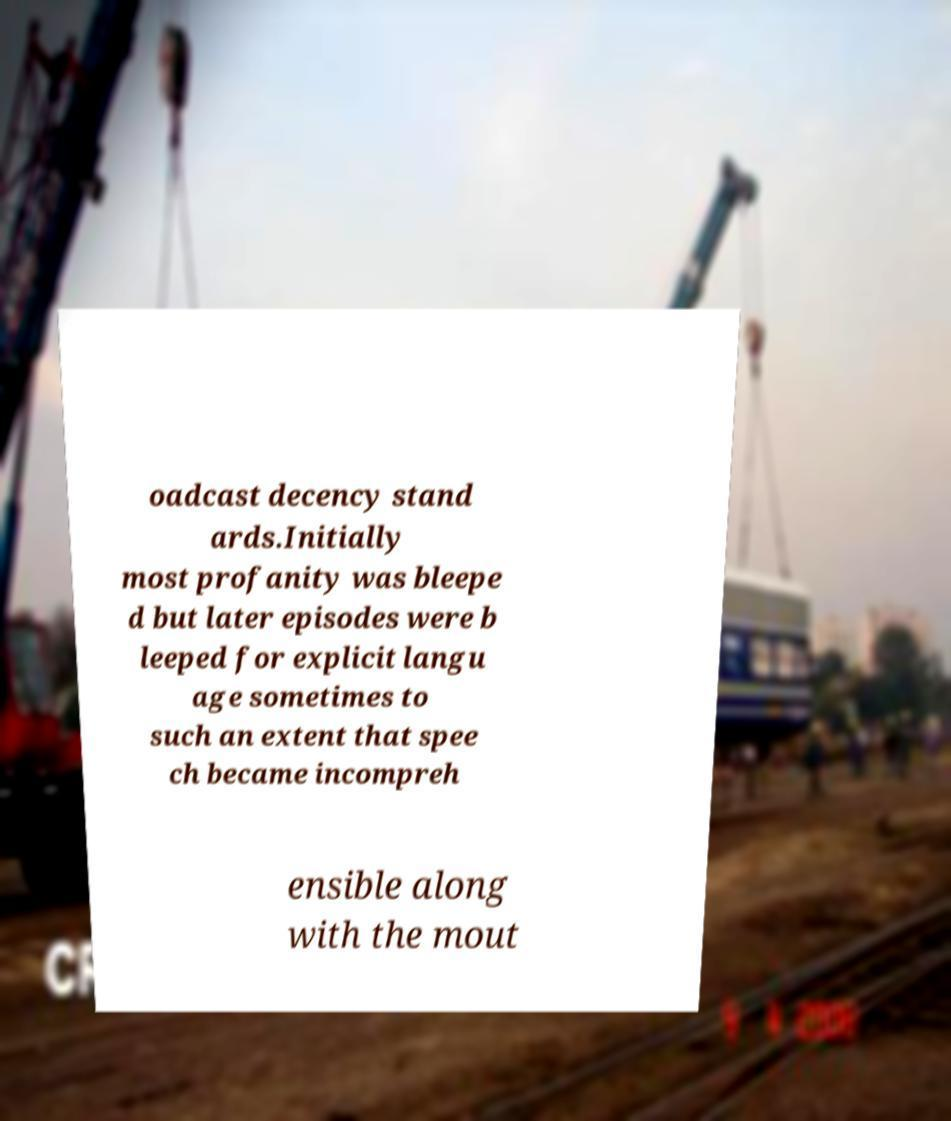Could you extract and type out the text from this image? oadcast decency stand ards.Initially most profanity was bleepe d but later episodes were b leeped for explicit langu age sometimes to such an extent that spee ch became incompreh ensible along with the mout 